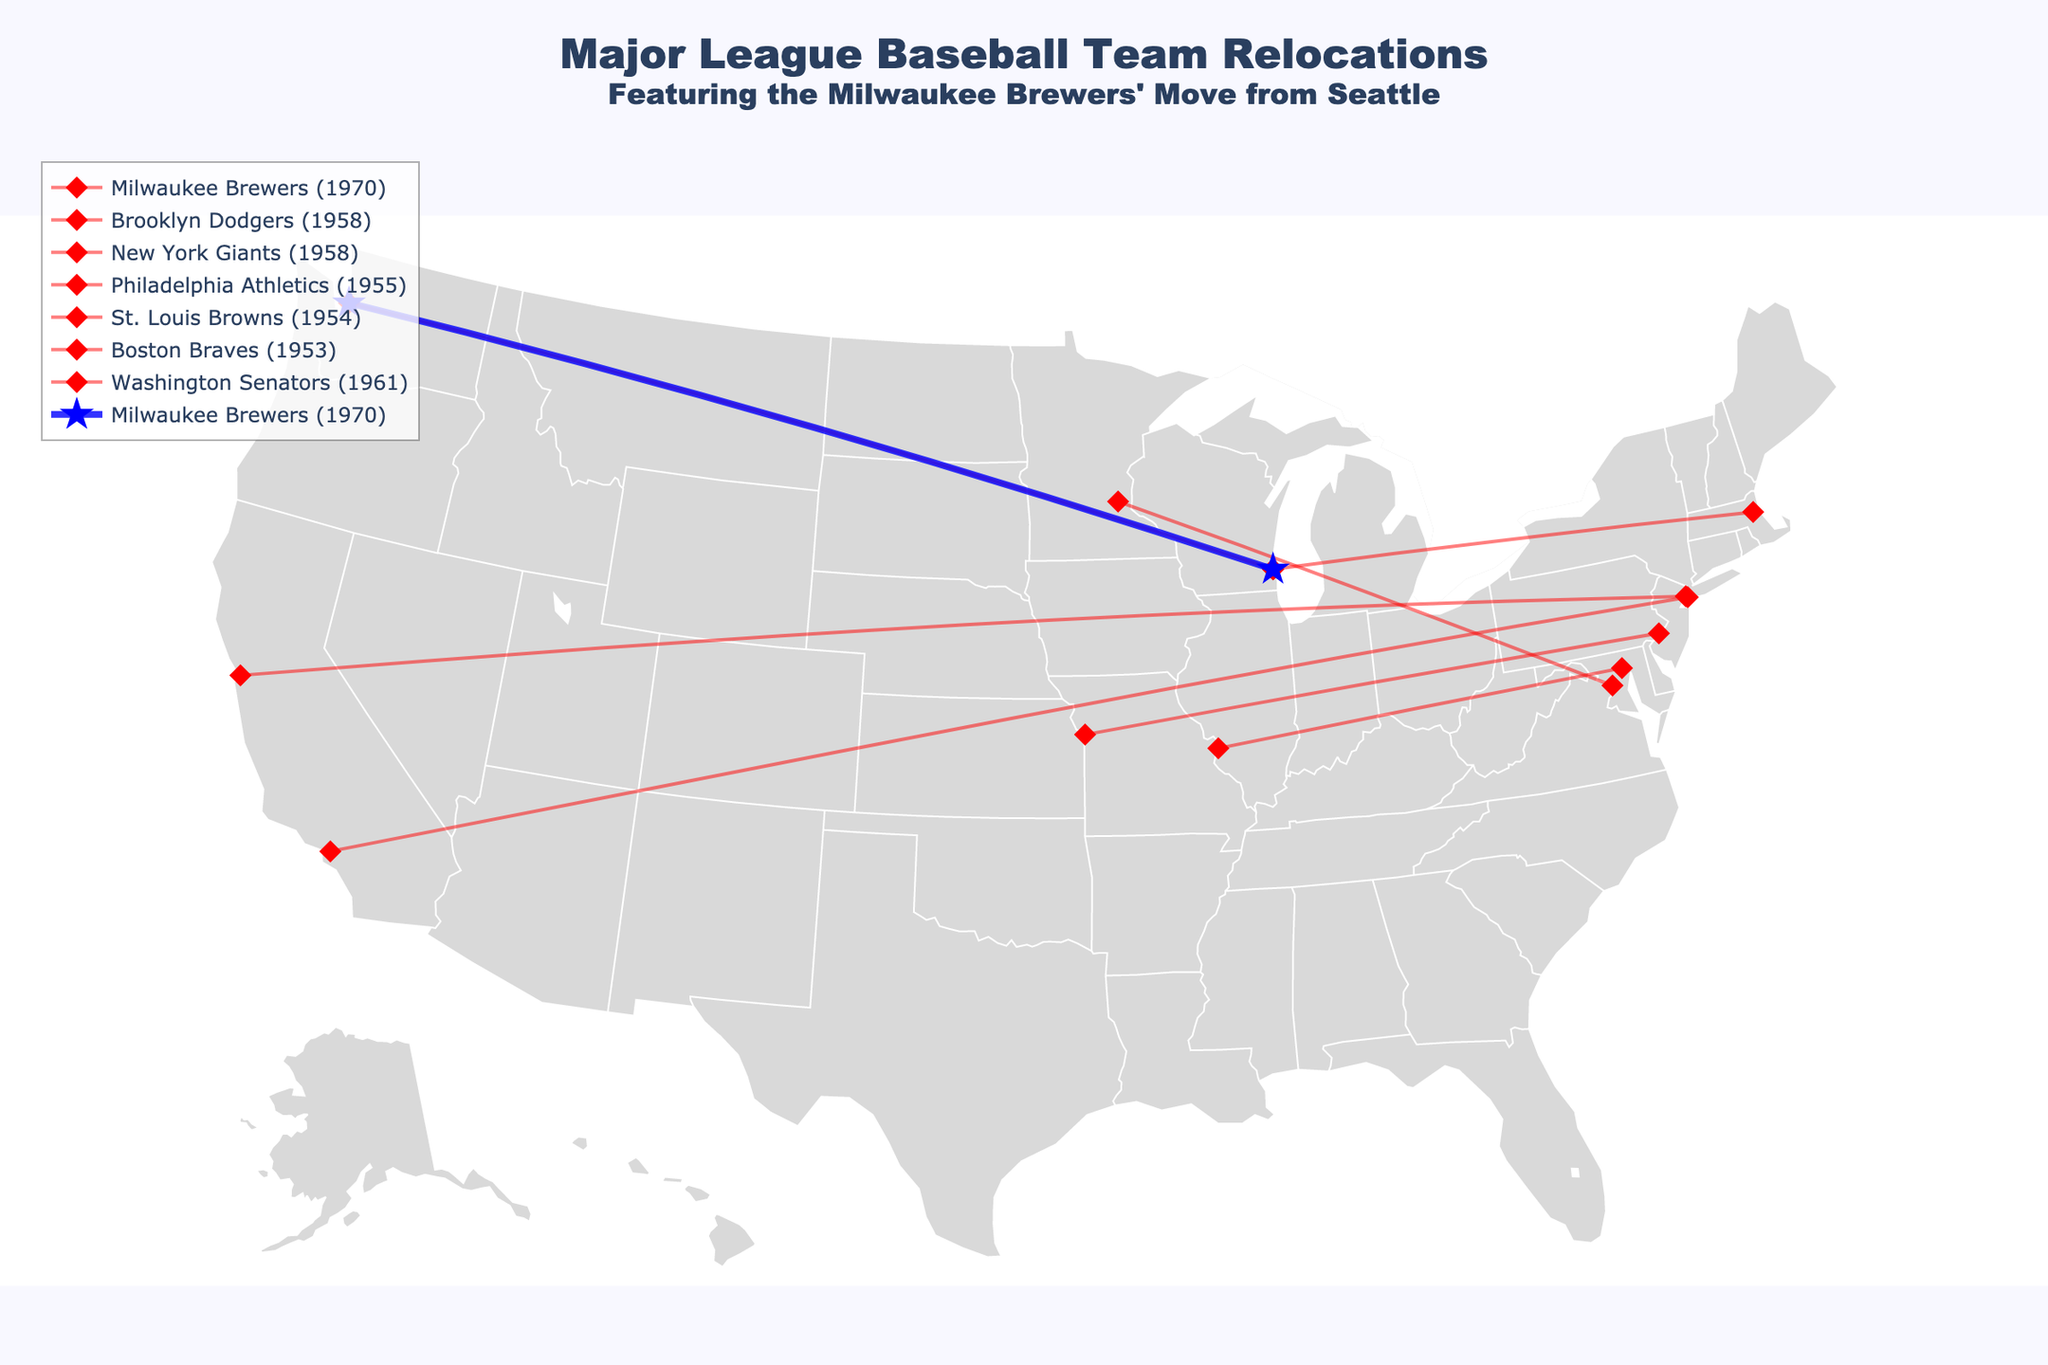what is the title of the plot? The title is located at the top of the plot and provides an overview of the data being visualized. It reads: "Major League Baseball Team Relocations" with a subtitle "Featuring the Milwaukee Brewers' Move from Seattle".
Answer: Major League Baseball Team Relocations How many teams are shown relocating in the plot? By counting each line representing a relocation on the map, we can determine there are 7 teams shown relocating.
Answer: 7 What year did the Milwaukee Brewers relocate? The year of relocation for each team is provided in the name label of their respective lines. For the Milwaukee Brewers, it indicates they relocated in 1970.
Answer: 1970 Between which two cities did the Brooklyn Dodgers relocate? The origin and destination cities for each team are shown next to their respective traces. The Brooklyn Dodgers' line shows the relocation from Brooklyn to Los Angeles.
Answer: Brooklyn to Los Angeles Which relocation happened first, the Boston Braves or the Washington Senators? By comparing the years provided for the relocations, the Boston Braves moved in 1953 and the Washington Senators in 1961, indicating the Boston Braves' relocation occurred first.
Answer: Boston Braves Which team moved the furthest distance? Comparing the lengths of the lines representing each team's relocation on the map, the Brooklyn Dodgers' move from Brooklyn to Los Angeles covers the greatest distance visually.
Answer: Brooklyn Dodgers How many teams relocated from the East coast to the West coast? By examining the coordinates and directions of the relocation paths, two teams moved from the East coast to the West coast: the Brooklyn Dodgers and the New York Giants.
Answer: 2 How many teams relocated in the 1950s according to the plot? Counting the teams that moved in the 1950s by checking the year mentioned for each relocation, there are four teams: Brooklyn Dodgers (1958), New York Giants (1958), Philadelphia Athletics (1955), and St. Louis Browns (1954).
Answer: 4 Which relocation involved moving to Milwaukee? There are two lines associated with Milwaukee as the destination, one for the Boston Braves moving there in 1953 and one for the Milwaukee Brewers moving there in 1970.
Answer: Boston Braves and Milwaukee Brewers Which city was left for Kansas City by the Philadelphia Athletics? The Philadelphia Athletics' relocation line shows they moved from Philadelphia to Kansas City, as indicated by the line and relevant label on the map.
Answer: Philadelphia 